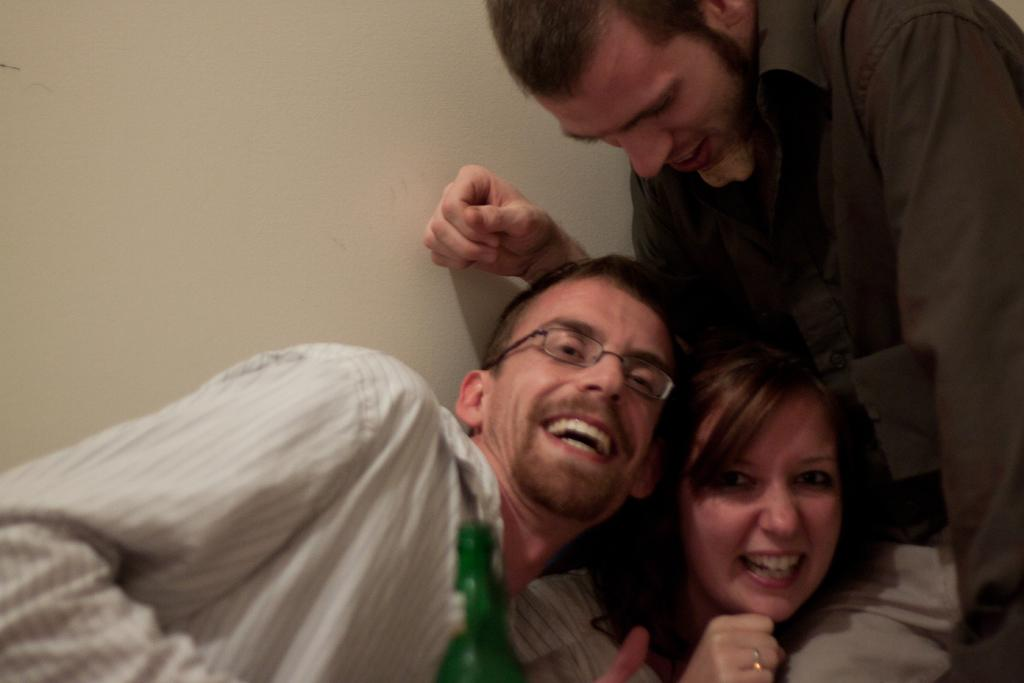How many people are in the image? There are three people in the image. What are the people doing in the image? All three people are laughing. What object is in front of the first person? There is a bottle in front of the first person. What can be seen in the background of the image? There is a wall in the background of the image. What type of country can be seen in the background of the image? There is no country visible in the image; it only shows a wall in the background. Can you tell me how many trucks are parked behind the wall in the image? There is no truck present in the image; it only shows a wall in the background. 